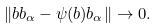<formula> <loc_0><loc_0><loc_500><loc_500>\| b b _ { \alpha } - \psi ( b ) b _ { \alpha } \| \rightarrow 0 .</formula> 